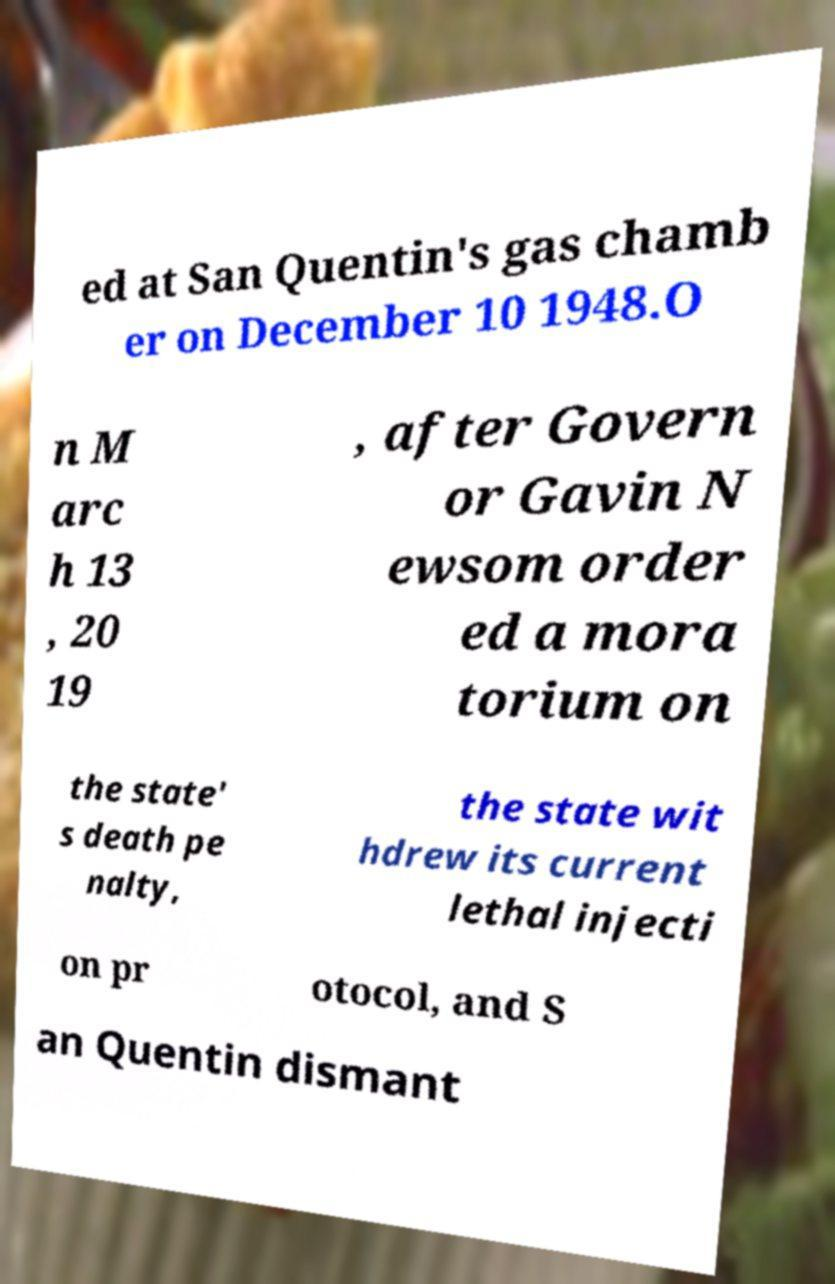There's text embedded in this image that I need extracted. Can you transcribe it verbatim? ed at San Quentin's gas chamb er on December 10 1948.O n M arc h 13 , 20 19 , after Govern or Gavin N ewsom order ed a mora torium on the state' s death pe nalty, the state wit hdrew its current lethal injecti on pr otocol, and S an Quentin dismant 